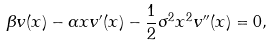<formula> <loc_0><loc_0><loc_500><loc_500>\beta v ( x ) - \alpha x v ^ { \prime } ( x ) - \frac { 1 } { 2 } \sigma ^ { 2 } x ^ { 2 } v ^ { \prime \prime } ( x ) = 0 ,</formula> 